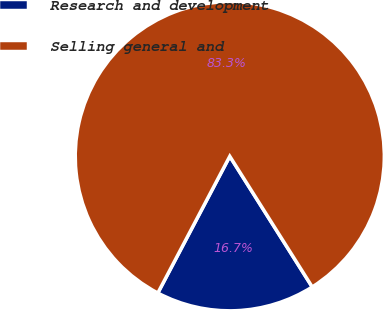Convert chart to OTSL. <chart><loc_0><loc_0><loc_500><loc_500><pie_chart><fcel>Research and development<fcel>Selling general and<nl><fcel>16.67%<fcel>83.33%<nl></chart> 